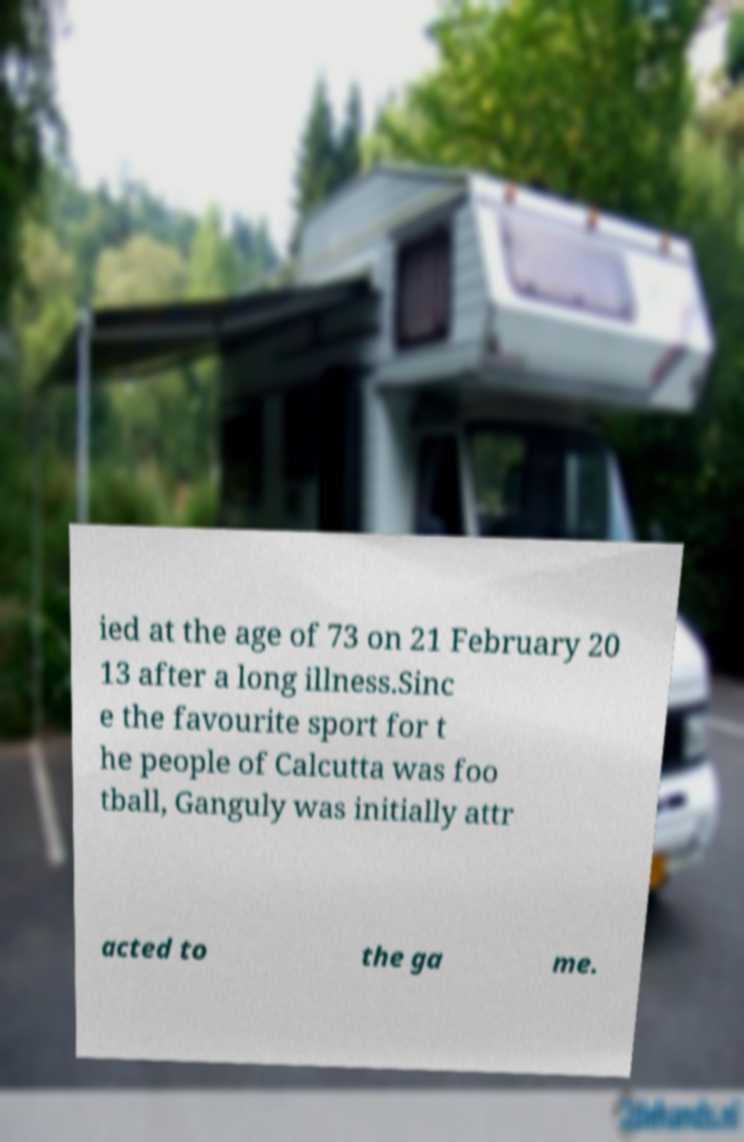Please identify and transcribe the text found in this image. ied at the age of 73 on 21 February 20 13 after a long illness.Sinc e the favourite sport for t he people of Calcutta was foo tball, Ganguly was initially attr acted to the ga me. 